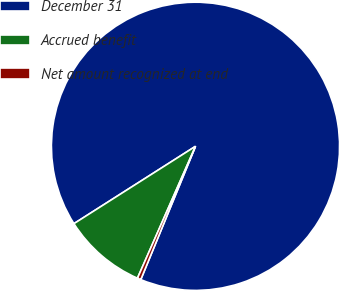Convert chart. <chart><loc_0><loc_0><loc_500><loc_500><pie_chart><fcel>December 31<fcel>Accrued benefit<fcel>Net amount recognized at end<nl><fcel>90.21%<fcel>9.38%<fcel>0.4%<nl></chart> 